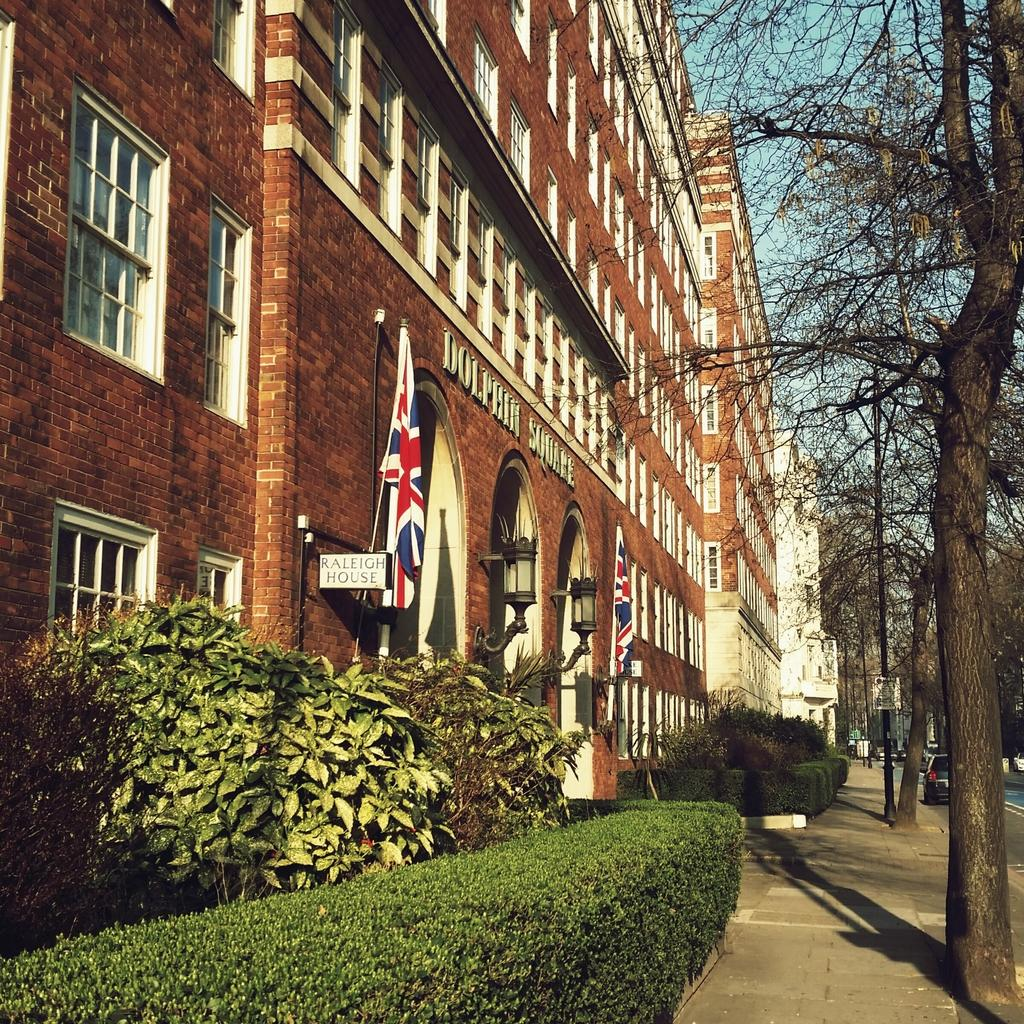What type of structure is visible in the image? There is a building in the image. What feature can be seen on the building? The building has windows. What additional objects are present in the image? There are flags, trees, plants, vehicles, and a board in the image. Where is the scarecrow located in the image? There is no scarecrow present in the image. What type of activity might be taking place in the cemetery in the image? There is no cemetery present in the image. 